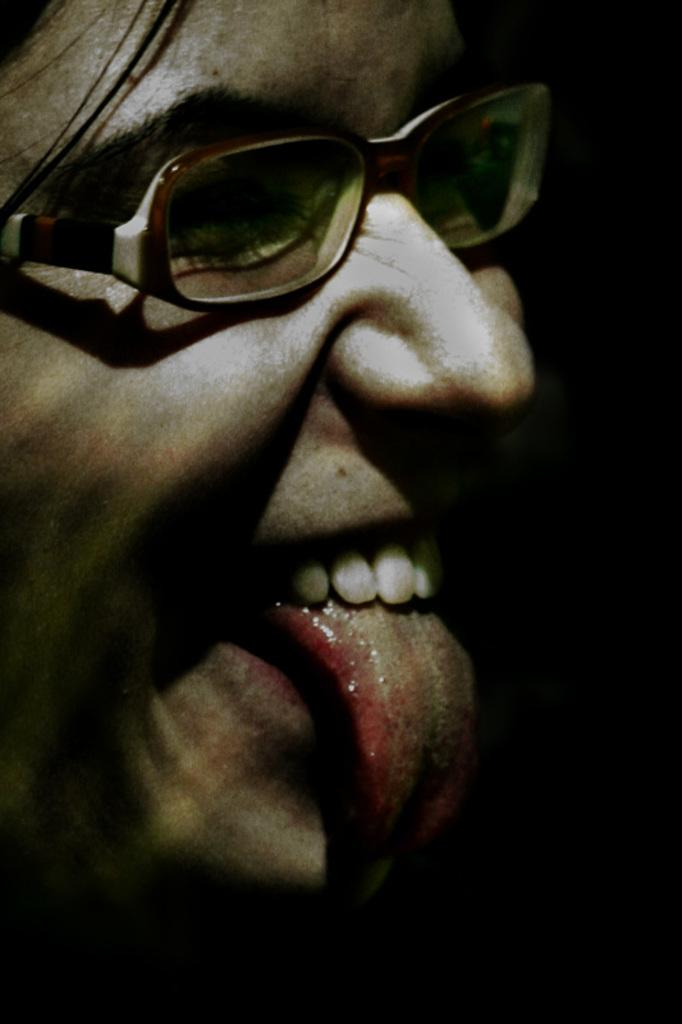What is present in the image? There is a person in the image. Can you describe the person's expression? The person is smiling. What type of pail is the person carrying in the image? There is no pail present in the image. What action does the person take to start the activity in the image? The image does not depict any activity or action being initiated. Is the person in danger of falling into quicksand in the image? There is no quicksand present in the image. 